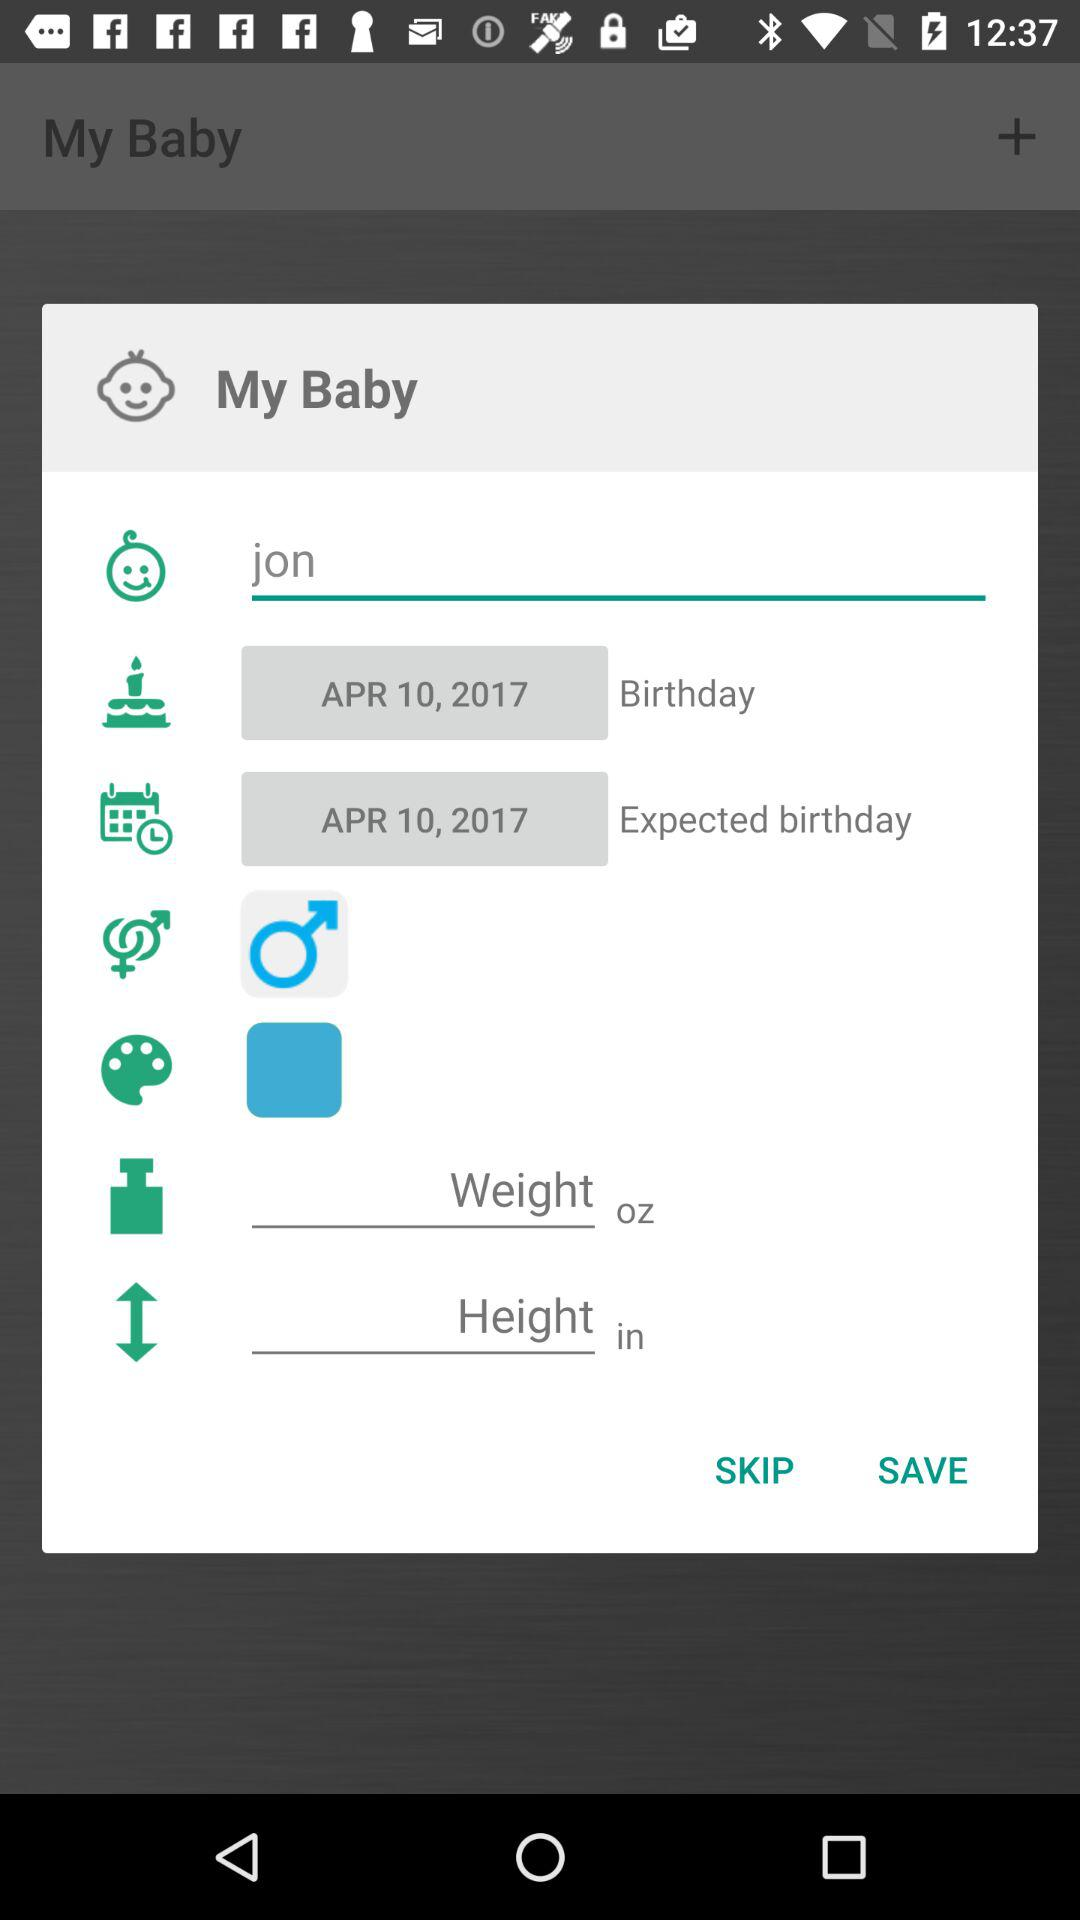What is the expected birthdate of the baby? The expected birthdate of the baby is April 10, 2017. 